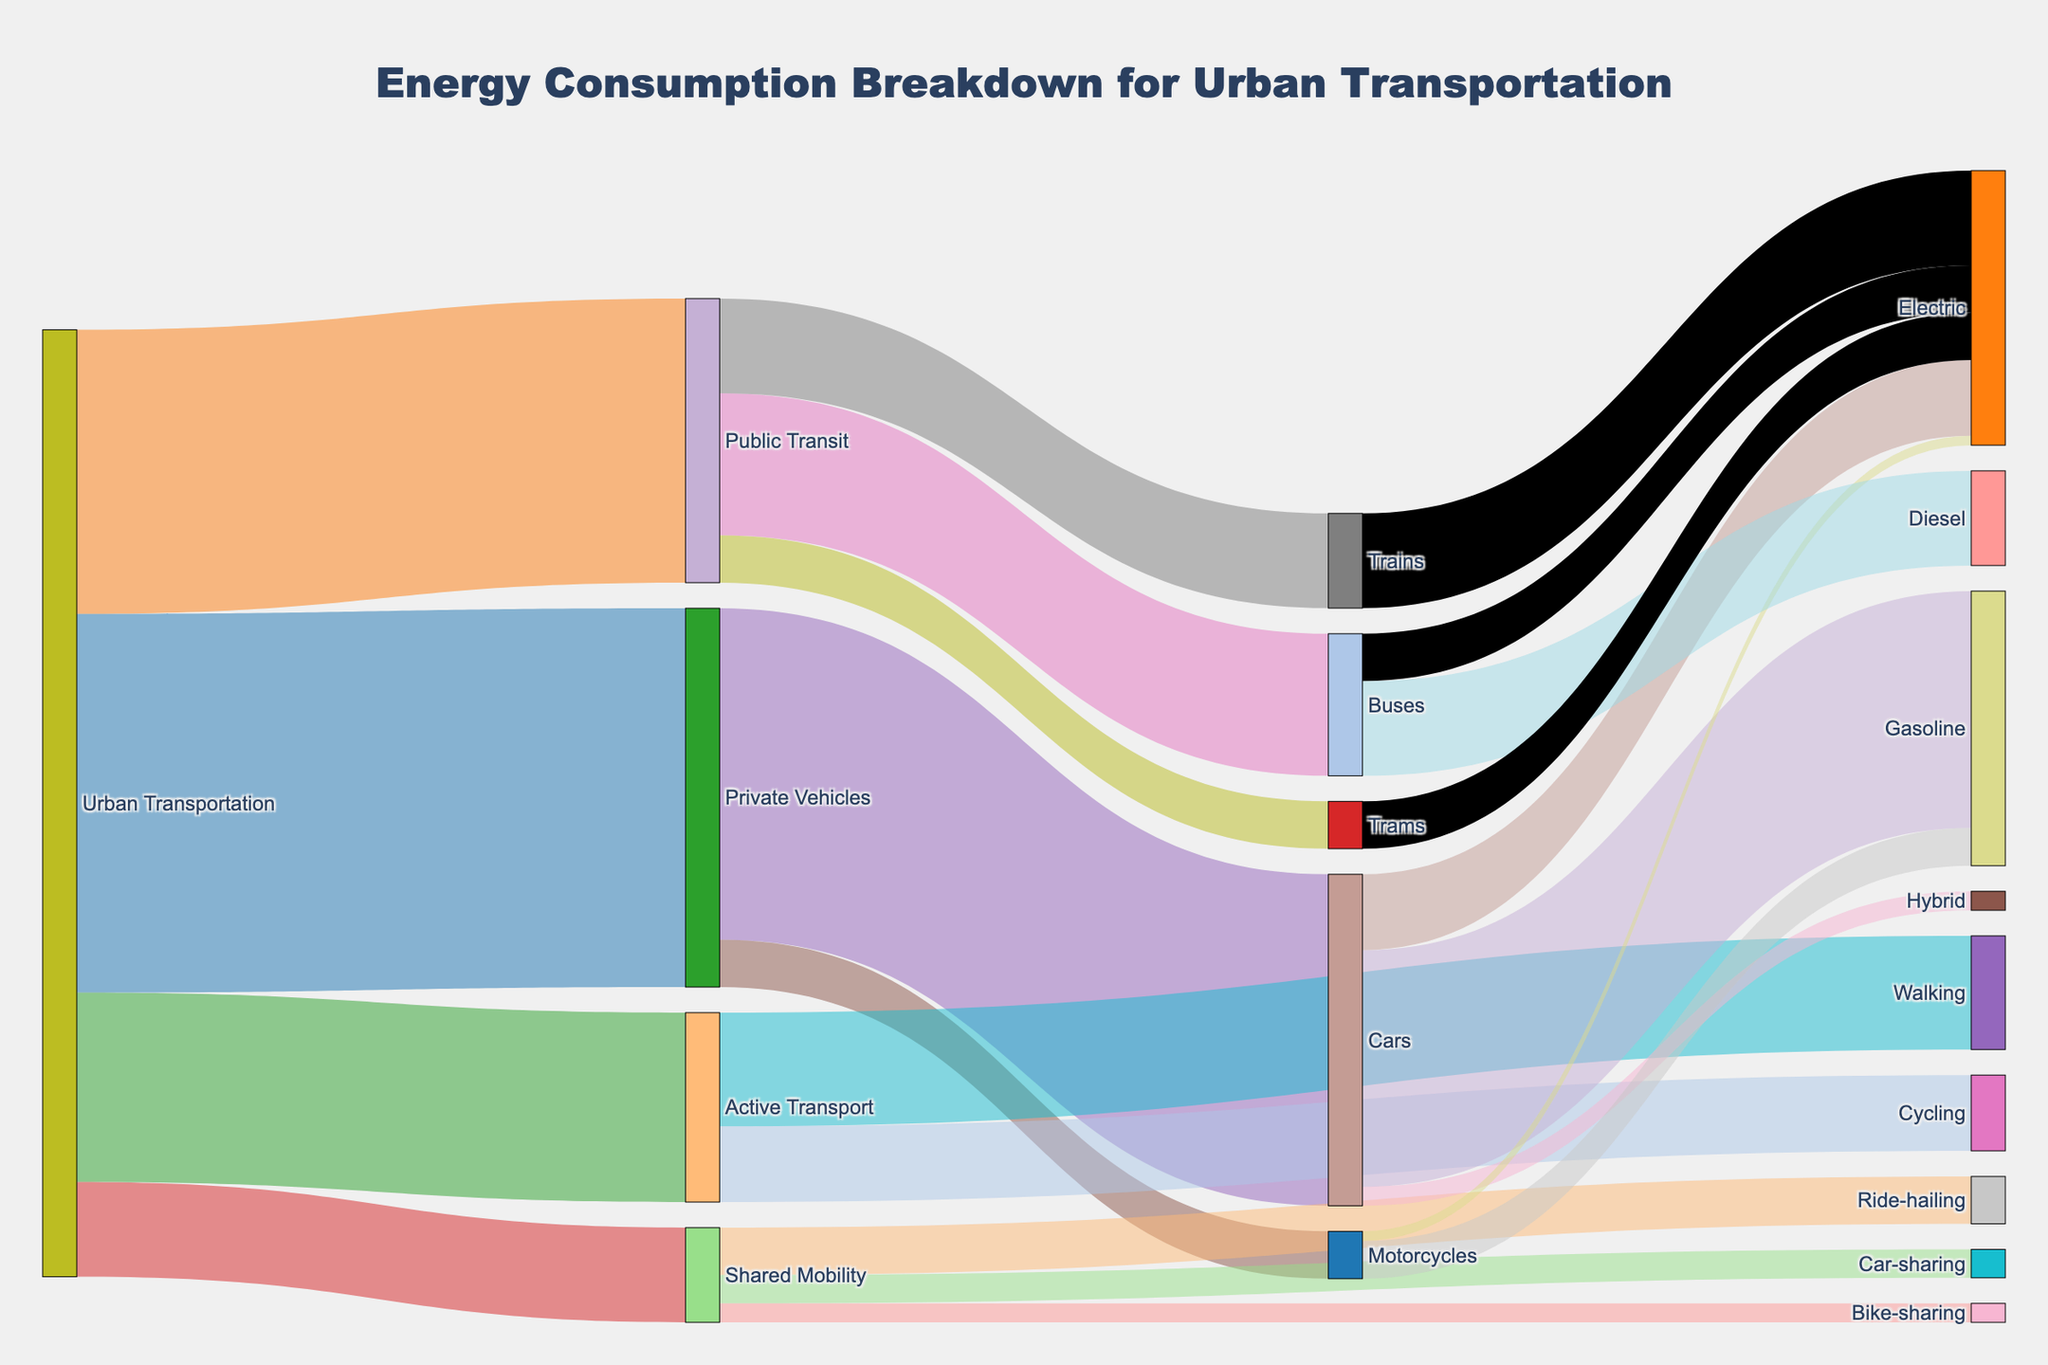What is the title of the Sankey diagram? The title of the Sankey diagram is displayed at the top of the figure and indicates what the diagram is about.
Answer: Energy Consumption Breakdown for Urban Transportation How many categories are there for urban transportation? To identify the categories, look at the primary nodes branching out from "Urban Transportation" – these are "Private Vehicles," "Public Transit," "Active Transport," and "Shared Mobility."
Answer: 4 Which mode of transportation consumes the most energy? The mode of transportation with the highest energy consumption has the thickest link connected to the "Urban Transportation" node.
Answer: Private Vehicles What is the total energy consumption for cars? Sum the energy consumption that goes into the "Cars" node, including "Gasoline," "Electric," and "Hybrid." 25 (Gasoline) + 8 (Electric) + 2 (Hybrid) = 35
Answer: 35 How does the energy consumption of buses compare to that of trains? Compare the values connected to the "Buses" and "Trains" nodes. Buses: 15, Trains: 10
Answer: Buses consume more energy than trains Which category under "Shared Mobility" uses the least energy? Look at the links coming out from the "Shared Mobility" node and identify the one with the smallest value.
Answer: Bike-sharing What is the total energy consumption for electric vehicles (cars, motorcycles, and buses)? Sum the values for "Electric" under the nodes "Cars," "Motorcycles," and "Buses." 8 (Cars) + 1 (Motorcycles) + 5 (Buses) = 14
Answer: 14 How much more energy does gasoline for cars consume compared to diesel for buses? Subtract the diesel consumption for buses from the gasoline consumption for cars. 25 (Gasoline for Cars) - 10 (Diesel for Buses) = 15
Answer: 15 Which form of active transport consumes more energy, walking or cycling? Compare the values connected to the "Walking" and "Cycling" nodes. Walking: 12, Cycling: 8
Answer: Walking What is the combined energy consumption for ride-hailing and car-sharing under shared mobility? Add the energy consumptions for "Ride-hailing" and "Car-sharing." 5 (Ride-hailing) + 3 (Car-sharing) = 8
Answer: 8 